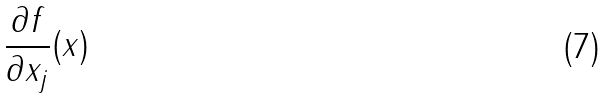<formula> <loc_0><loc_0><loc_500><loc_500>\frac { \partial f } { \partial x _ { j } } ( x )</formula> 